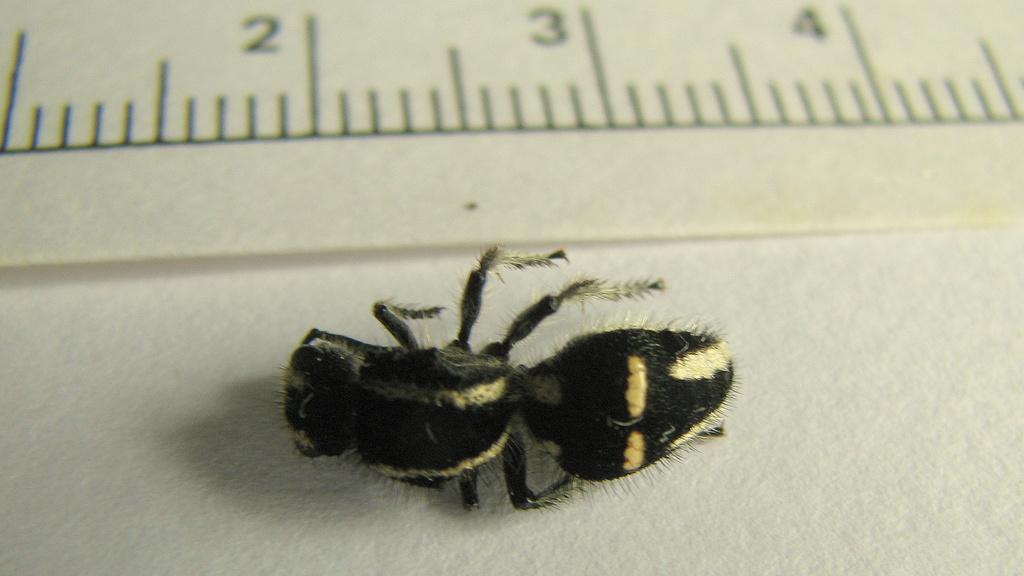Describe this image in one or two sentences. In this image, we can see a bee and we can see a scale which is marked on the paper. 